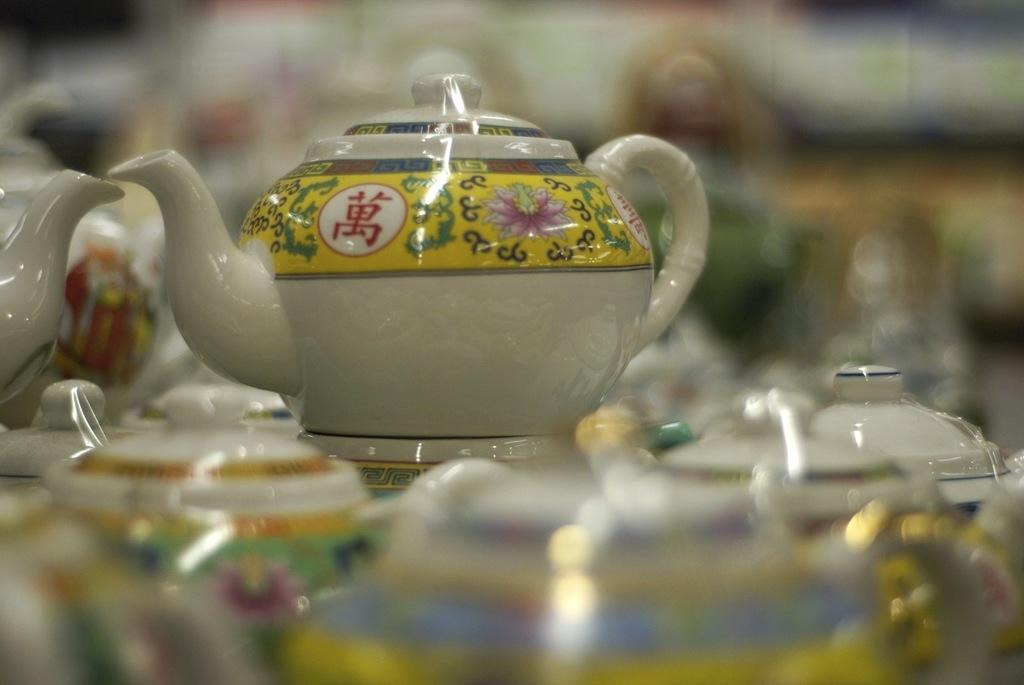What is the main subject of the image? The main subject of the image is many kettles. What can be observed about the appearance of the kettles? The kettles have designs on them. Can you describe the background of the image? The background of the image is blurred. How many vases are visible in the image? There is no mention of vases in the provided facts. However, based on the facts given, we can determine that there are no vases visible in the image. 